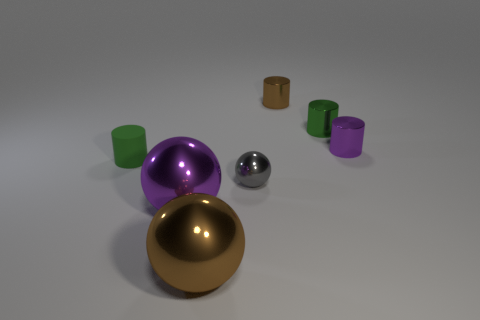Subtract all purple shiny cylinders. How many cylinders are left? 3 Subtract 2 cylinders. How many cylinders are left? 2 Add 1 small brown metallic cylinders. How many objects exist? 8 Subtract all purple cylinders. How many cylinders are left? 3 Subtract all spheres. How many objects are left? 4 Subtract all tiny green metal objects. Subtract all tiny metal cylinders. How many objects are left? 3 Add 6 tiny brown metallic things. How many tiny brown metallic things are left? 7 Add 1 big gray spheres. How many big gray spheres exist? 1 Subtract 1 purple cylinders. How many objects are left? 6 Subtract all yellow cylinders. Subtract all yellow spheres. How many cylinders are left? 4 